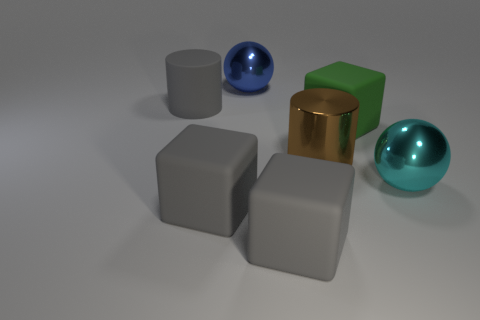There is a blue object that is the same size as the cyan shiny object; what is it made of?
Your answer should be very brief. Metal. The large rubber thing that is both behind the large cyan metal thing and on the right side of the gray matte cylinder has what shape?
Your response must be concise. Cube. The metal cylinder that is the same size as the green object is what color?
Provide a short and direct response. Brown. Does the blue shiny sphere behind the large green rubber cube have the same size as the cylinder that is on the right side of the blue sphere?
Ensure brevity in your answer.  Yes. There is a blue shiny object that is on the right side of the gray object that is behind the big thing that is right of the green matte cube; what is its size?
Make the answer very short. Large. The green thing that is on the left side of the big ball that is in front of the large brown shiny thing is what shape?
Your answer should be very brief. Cube. There is a block to the left of the blue thing; is its color the same as the rubber cylinder?
Offer a terse response. Yes. What is the color of the big matte object that is on the left side of the big blue metal sphere and on the right side of the gray cylinder?
Make the answer very short. Gray. Is there a brown object made of the same material as the big blue object?
Your answer should be very brief. Yes. What is the size of the blue shiny ball?
Your response must be concise. Large. 